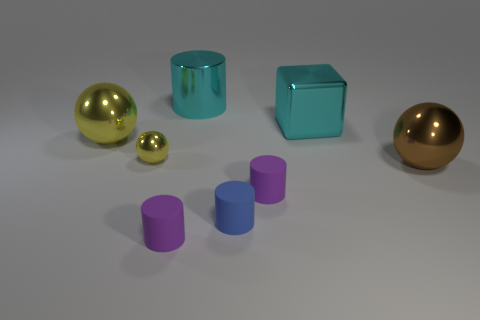Subtract all red cylinders. Subtract all cyan blocks. How many cylinders are left? 4 Add 1 big shiny cylinders. How many objects exist? 9 Subtract all cubes. How many objects are left? 7 Add 2 matte objects. How many matte objects exist? 5 Subtract 0 gray cylinders. How many objects are left? 8 Subtract all big cylinders. Subtract all tiny purple rubber cylinders. How many objects are left? 5 Add 1 big brown shiny objects. How many big brown shiny objects are left? 2 